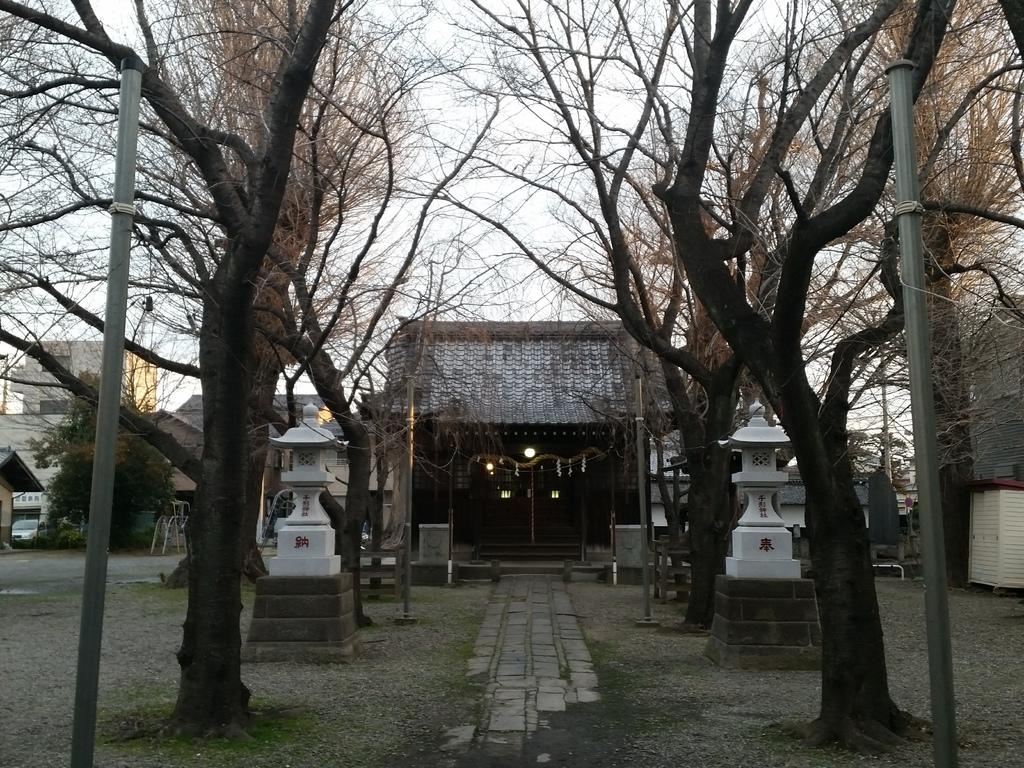What can be seen running through the image? There is a path in the image. What type of vegetation is present alongside the path? Trees are present on either side of the path. What structures are visible on either side of the path? Poles and sculptures are present on either side of the path. What can be seen in the distance in the image? There are houses in the background of the image. What is visible above the houses in the image? The sky is visible in the background of the image. What type of pear is being used to write with ink in the image? There is no pear or ink present in the image. 